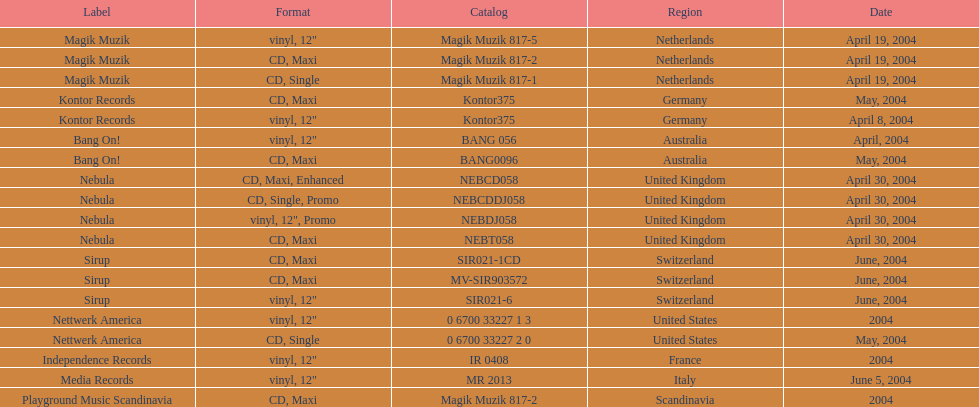What are all of the regions the title was released in? Netherlands, Netherlands, Netherlands, Germany, Germany, Australia, Australia, United Kingdom, United Kingdom, United Kingdom, United Kingdom, Switzerland, Switzerland, Switzerland, United States, United States, France, Italy, Scandinavia. And under which labels were they released? Magik Muzik, Magik Muzik, Magik Muzik, Kontor Records, Kontor Records, Bang On!, Bang On!, Nebula, Nebula, Nebula, Nebula, Sirup, Sirup, Sirup, Nettwerk America, Nettwerk America, Independence Records, Media Records, Playground Music Scandinavia. Which label released the song in france? Independence Records. 